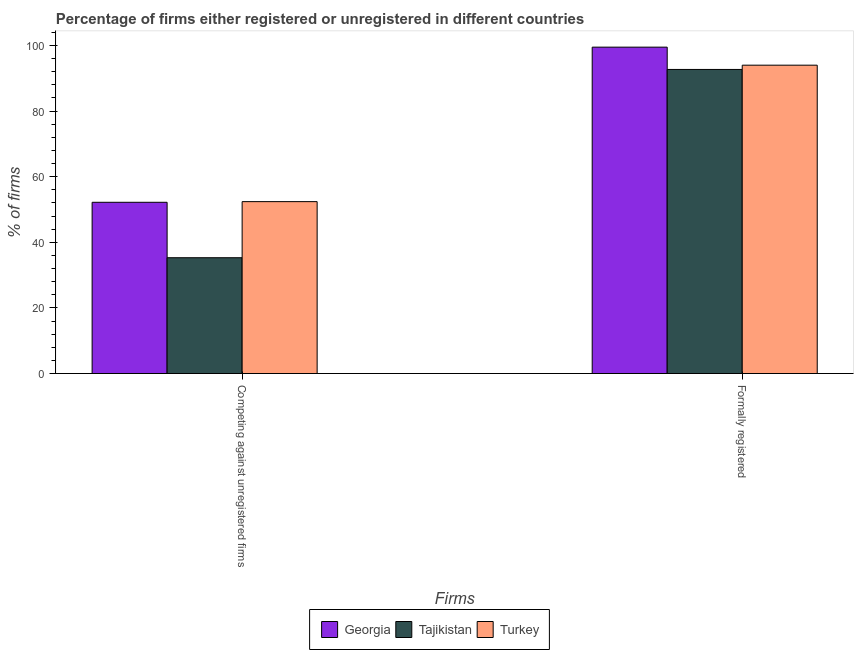How many groups of bars are there?
Offer a very short reply. 2. Are the number of bars per tick equal to the number of legend labels?
Offer a terse response. Yes. Are the number of bars on each tick of the X-axis equal?
Your answer should be compact. Yes. What is the label of the 2nd group of bars from the left?
Offer a terse response. Formally registered. What is the percentage of registered firms in Turkey?
Offer a very short reply. 52.4. Across all countries, what is the maximum percentage of formally registered firms?
Your response must be concise. 99.5. Across all countries, what is the minimum percentage of formally registered firms?
Provide a short and direct response. 92.7. In which country was the percentage of registered firms minimum?
Provide a succinct answer. Tajikistan. What is the total percentage of formally registered firms in the graph?
Make the answer very short. 286.2. What is the difference between the percentage of registered firms in Turkey and that in Georgia?
Your response must be concise. 0.2. What is the difference between the percentage of formally registered firms in Tajikistan and the percentage of registered firms in Georgia?
Ensure brevity in your answer.  40.5. What is the average percentage of registered firms per country?
Ensure brevity in your answer.  46.63. What is the difference between the percentage of formally registered firms and percentage of registered firms in Tajikistan?
Provide a short and direct response. 57.4. What is the ratio of the percentage of formally registered firms in Turkey to that in Georgia?
Ensure brevity in your answer.  0.94. Is the percentage of registered firms in Tajikistan less than that in Georgia?
Your answer should be compact. Yes. What does the 3rd bar from the left in Competing against unregistered firms represents?
Give a very brief answer. Turkey. What does the 3rd bar from the right in Competing against unregistered firms represents?
Offer a very short reply. Georgia. How many bars are there?
Your response must be concise. 6. Are all the bars in the graph horizontal?
Give a very brief answer. No. What is the difference between two consecutive major ticks on the Y-axis?
Ensure brevity in your answer.  20. Are the values on the major ticks of Y-axis written in scientific E-notation?
Offer a terse response. No. How many legend labels are there?
Provide a succinct answer. 3. What is the title of the graph?
Provide a short and direct response. Percentage of firms either registered or unregistered in different countries. What is the label or title of the X-axis?
Your answer should be very brief. Firms. What is the label or title of the Y-axis?
Your answer should be compact. % of firms. What is the % of firms of Georgia in Competing against unregistered firms?
Offer a very short reply. 52.2. What is the % of firms in Tajikistan in Competing against unregistered firms?
Make the answer very short. 35.3. What is the % of firms of Turkey in Competing against unregistered firms?
Make the answer very short. 52.4. What is the % of firms in Georgia in Formally registered?
Give a very brief answer. 99.5. What is the % of firms of Tajikistan in Formally registered?
Your answer should be compact. 92.7. What is the % of firms in Turkey in Formally registered?
Your answer should be very brief. 94. Across all Firms, what is the maximum % of firms in Georgia?
Offer a very short reply. 99.5. Across all Firms, what is the maximum % of firms of Tajikistan?
Your answer should be compact. 92.7. Across all Firms, what is the maximum % of firms of Turkey?
Ensure brevity in your answer.  94. Across all Firms, what is the minimum % of firms of Georgia?
Provide a succinct answer. 52.2. Across all Firms, what is the minimum % of firms in Tajikistan?
Provide a succinct answer. 35.3. Across all Firms, what is the minimum % of firms of Turkey?
Offer a terse response. 52.4. What is the total % of firms of Georgia in the graph?
Give a very brief answer. 151.7. What is the total % of firms of Tajikistan in the graph?
Your response must be concise. 128. What is the total % of firms in Turkey in the graph?
Keep it short and to the point. 146.4. What is the difference between the % of firms in Georgia in Competing against unregistered firms and that in Formally registered?
Provide a succinct answer. -47.3. What is the difference between the % of firms of Tajikistan in Competing against unregistered firms and that in Formally registered?
Make the answer very short. -57.4. What is the difference between the % of firms of Turkey in Competing against unregistered firms and that in Formally registered?
Your answer should be very brief. -41.6. What is the difference between the % of firms of Georgia in Competing against unregistered firms and the % of firms of Tajikistan in Formally registered?
Give a very brief answer. -40.5. What is the difference between the % of firms in Georgia in Competing against unregistered firms and the % of firms in Turkey in Formally registered?
Keep it short and to the point. -41.8. What is the difference between the % of firms of Tajikistan in Competing against unregistered firms and the % of firms of Turkey in Formally registered?
Your response must be concise. -58.7. What is the average % of firms in Georgia per Firms?
Your answer should be compact. 75.85. What is the average % of firms of Tajikistan per Firms?
Keep it short and to the point. 64. What is the average % of firms in Turkey per Firms?
Your answer should be compact. 73.2. What is the difference between the % of firms of Tajikistan and % of firms of Turkey in Competing against unregistered firms?
Provide a short and direct response. -17.1. What is the difference between the % of firms in Georgia and % of firms in Tajikistan in Formally registered?
Offer a very short reply. 6.8. What is the difference between the % of firms of Georgia and % of firms of Turkey in Formally registered?
Your answer should be very brief. 5.5. What is the ratio of the % of firms of Georgia in Competing against unregistered firms to that in Formally registered?
Your answer should be compact. 0.52. What is the ratio of the % of firms of Tajikistan in Competing against unregistered firms to that in Formally registered?
Make the answer very short. 0.38. What is the ratio of the % of firms in Turkey in Competing against unregistered firms to that in Formally registered?
Ensure brevity in your answer.  0.56. What is the difference between the highest and the second highest % of firms in Georgia?
Give a very brief answer. 47.3. What is the difference between the highest and the second highest % of firms in Tajikistan?
Offer a terse response. 57.4. What is the difference between the highest and the second highest % of firms in Turkey?
Give a very brief answer. 41.6. What is the difference between the highest and the lowest % of firms in Georgia?
Your answer should be compact. 47.3. What is the difference between the highest and the lowest % of firms in Tajikistan?
Your answer should be very brief. 57.4. What is the difference between the highest and the lowest % of firms in Turkey?
Your response must be concise. 41.6. 